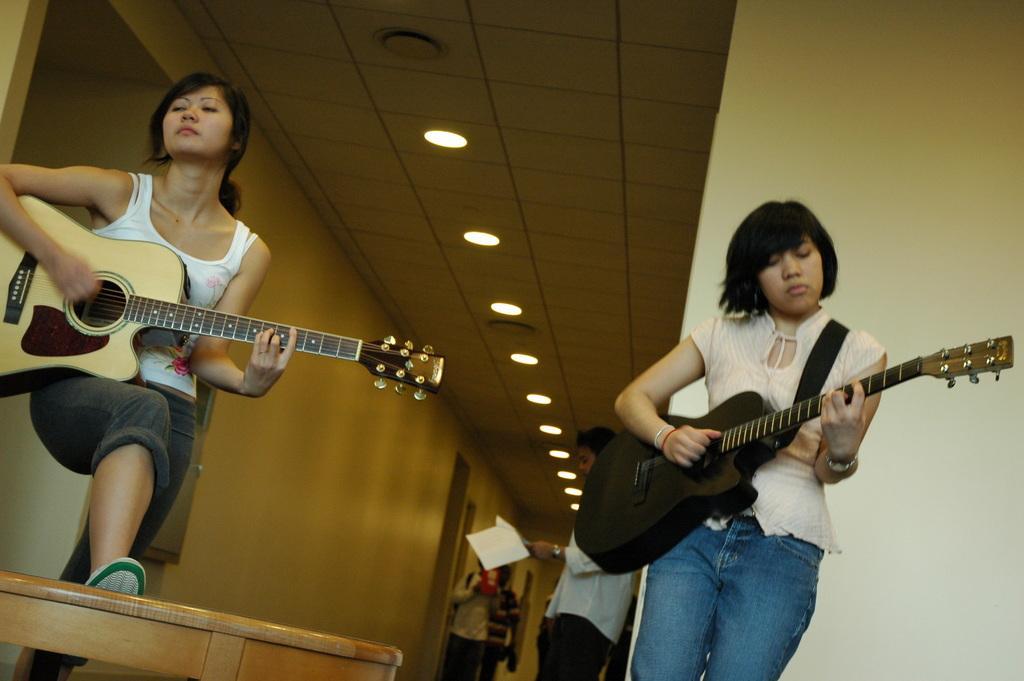Could you give a brief overview of what you see in this image? In this picture there are two women standing and playing guitar. In the background there are people standing and there are lights attached to the roof. 